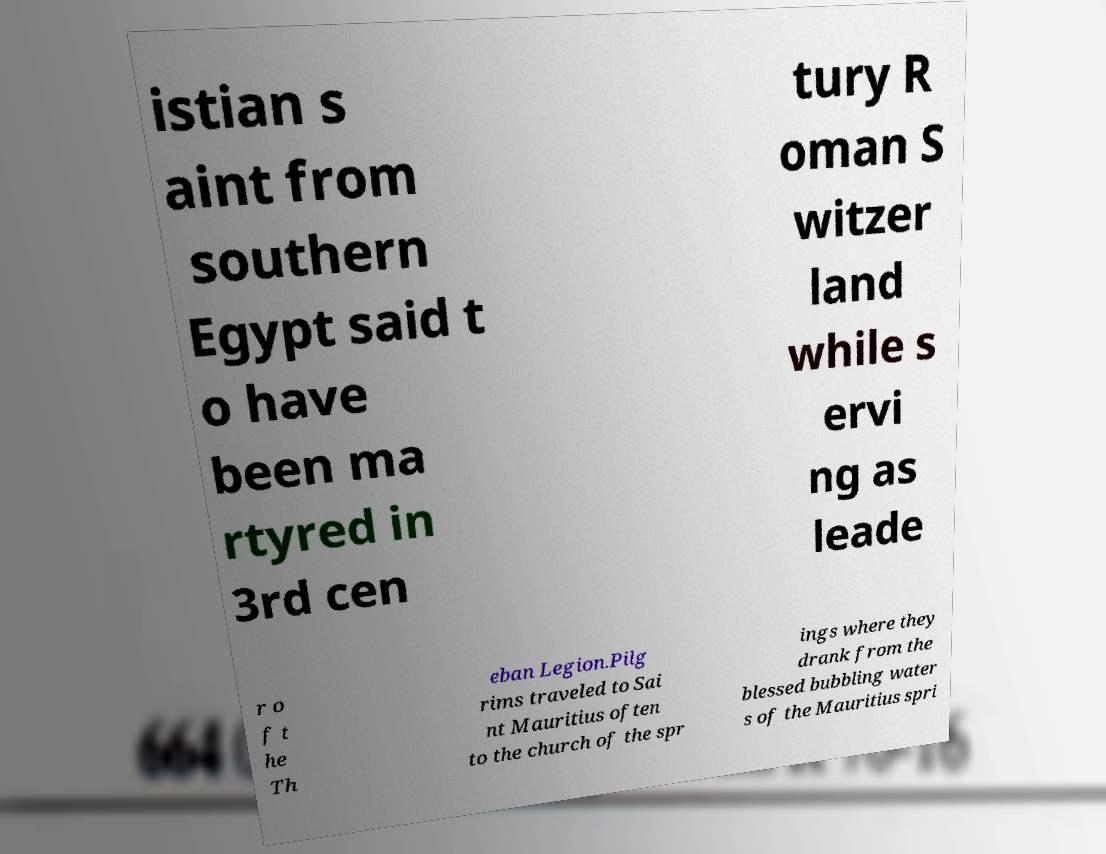Can you accurately transcribe the text from the provided image for me? istian s aint from southern Egypt said t o have been ma rtyred in 3rd cen tury R oman S witzer land while s ervi ng as leade r o f t he Th eban Legion.Pilg rims traveled to Sai nt Mauritius often to the church of the spr ings where they drank from the blessed bubbling water s of the Mauritius spri 